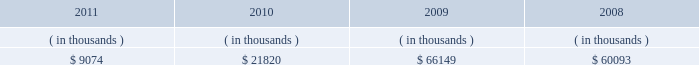Entergy new orleans , inc .
Management 2019s financial discussion and analysis also in addition to the contractual obligations , entergy new orleans has $ 53.7 million of unrecognized tax benefits and interest net of unused tax attributes and payments for which the timing of payments beyond 12 months cannot be reasonably estimated due to uncertainties in the timing of effective settlement of tax positions .
See note 3 to the financial statements for additional information regarding unrecognized tax benefits .
The planned capital investment estimate for entergy new orleans reflects capital required to support existing business .
The estimated capital expenditures are subject to periodic review and modification and may vary based on the ongoing effects of regulatory constraints , environmental compliance , market volatility , economic trends , changes in project plans , and the ability to access capital .
Management provides more information on long-term debt and preferred stock maturities in notes 5 and 6 and to the financial statements .
As an indirect , wholly-owned subsidiary of entergy corporation , entergy new orleans pays dividends from its earnings at a percentage determined monthly .
Entergy new orleans 2019s long-term debt indentures contain restrictions on the payment of cash dividends or other distributions on its common and preferred stock .
Sources of capital entergy new orleans 2019s sources to meet its capital requirements include : internally generated funds ; cash on hand ; and debt and preferred stock issuances .
Entergy new orleans may refinance , redeem , or otherwise retire debt and preferred stock prior to maturity , to the extent market conditions and interest and dividend rates are favorable .
Entergy new orleans 2019s receivables from the money pool were as follows as of december 31 for each of the following years: .
See note 4 to the financial statements for a description of the money pool .
Entergy new orleans has obtained short-term borrowing authorization from the ferc under which it may borrow through october 2013 , up to the aggregate amount , at any one time outstanding , of $ 100 million .
See note 4 to the financial statements for further discussion of entergy new orleans 2019s short-term borrowing limits .
The long-term securities issuances of entergy new orleans are limited to amounts authorized by the city council , and the current authorization extends through july 2012 .
Entergy louisiana 2019s ninemile point unit 6 self-build project in june 2011 , entergy louisiana filed with the lpsc an application seeking certification that the public necessity and convenience would be served by entergy louisiana 2019s construction of a combined-cycle gas turbine generating facility ( ninemile 6 ) at its existing ninemile point electric generating station .
Ninemile 6 will be a nominally-sized 550 mw unit that is estimated to cost approximately $ 721 million to construct , excluding interconnection and transmission upgrades .
Entergy gulf states louisiana joined in the application , seeking certification of its purchase under a life-of-unit power purchase agreement of up to 35% ( 35 % ) of the capacity and energy generated by ninemile 6 .
The ninemile 6 capacity and energy is proposed to be allocated 55% ( 55 % ) to entergy louisiana , 25% ( 25 % ) to entergy gulf states louisiana , and 20% ( 20 % ) to entergy new orleans .
In february 2012 the city council passed a resolution authorizing entergy new orleans to purchase 20% ( 20 % ) of the ninemile 6 energy and capacity .
If approvals are obtained from the lpsc and other permitting agencies , ninemile 6 construction is .
What was the average entergy new orleans 2019s receivables from the money pool from 2008 to 2011? 
Computations: (((60093 + (66149 + (9074 + 21820))) + 4) / 2)
Answer: 78570.0. Entergy new orleans , inc .
Management 2019s financial discussion and analysis also in addition to the contractual obligations , entergy new orleans has $ 53.7 million of unrecognized tax benefits and interest net of unused tax attributes and payments for which the timing of payments beyond 12 months cannot be reasonably estimated due to uncertainties in the timing of effective settlement of tax positions .
See note 3 to the financial statements for additional information regarding unrecognized tax benefits .
The planned capital investment estimate for entergy new orleans reflects capital required to support existing business .
The estimated capital expenditures are subject to periodic review and modification and may vary based on the ongoing effects of regulatory constraints , environmental compliance , market volatility , economic trends , changes in project plans , and the ability to access capital .
Management provides more information on long-term debt and preferred stock maturities in notes 5 and 6 and to the financial statements .
As an indirect , wholly-owned subsidiary of entergy corporation , entergy new orleans pays dividends from its earnings at a percentage determined monthly .
Entergy new orleans 2019s long-term debt indentures contain restrictions on the payment of cash dividends or other distributions on its common and preferred stock .
Sources of capital entergy new orleans 2019s sources to meet its capital requirements include : internally generated funds ; cash on hand ; and debt and preferred stock issuances .
Entergy new orleans may refinance , redeem , or otherwise retire debt and preferred stock prior to maturity , to the extent market conditions and interest and dividend rates are favorable .
Entergy new orleans 2019s receivables from the money pool were as follows as of december 31 for each of the following years: .
See note 4 to the financial statements for a description of the money pool .
Entergy new orleans has obtained short-term borrowing authorization from the ferc under which it may borrow through october 2013 , up to the aggregate amount , at any one time outstanding , of $ 100 million .
See note 4 to the financial statements for further discussion of entergy new orleans 2019s short-term borrowing limits .
The long-term securities issuances of entergy new orleans are limited to amounts authorized by the city council , and the current authorization extends through july 2012 .
Entergy louisiana 2019s ninemile point unit 6 self-build project in june 2011 , entergy louisiana filed with the lpsc an application seeking certification that the public necessity and convenience would be served by entergy louisiana 2019s construction of a combined-cycle gas turbine generating facility ( ninemile 6 ) at its existing ninemile point electric generating station .
Ninemile 6 will be a nominally-sized 550 mw unit that is estimated to cost approximately $ 721 million to construct , excluding interconnection and transmission upgrades .
Entergy gulf states louisiana joined in the application , seeking certification of its purchase under a life-of-unit power purchase agreement of up to 35% ( 35 % ) of the capacity and energy generated by ninemile 6 .
The ninemile 6 capacity and energy is proposed to be allocated 55% ( 55 % ) to entergy louisiana , 25% ( 25 % ) to entergy gulf states louisiana , and 20% ( 20 % ) to entergy new orleans .
In february 2012 the city council passed a resolution authorizing entergy new orleans to purchase 20% ( 20 % ) of the ninemile 6 energy and capacity .
If approvals are obtained from the lpsc and other permitting agencies , ninemile 6 construction is .
What was the ratio of the ninemile 6 mw to the cost of the construction? 
Computations: (721 / 550)
Answer: 1.31091. 